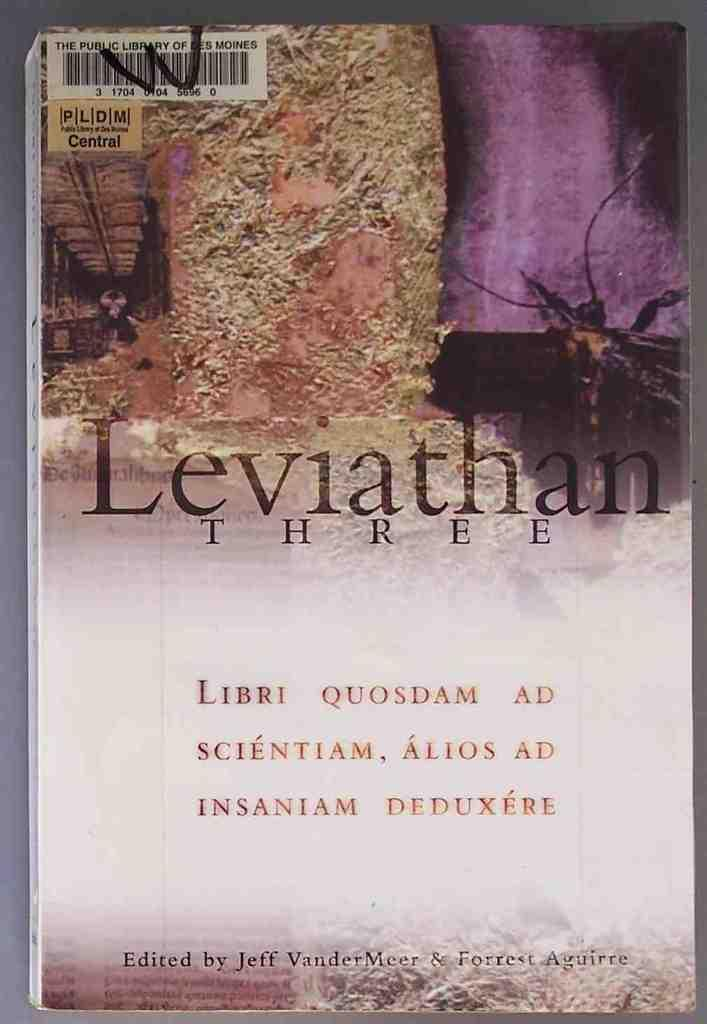<image>
Summarize the visual content of the image. Copy of Leviathan Three from the Des Moines public library. 